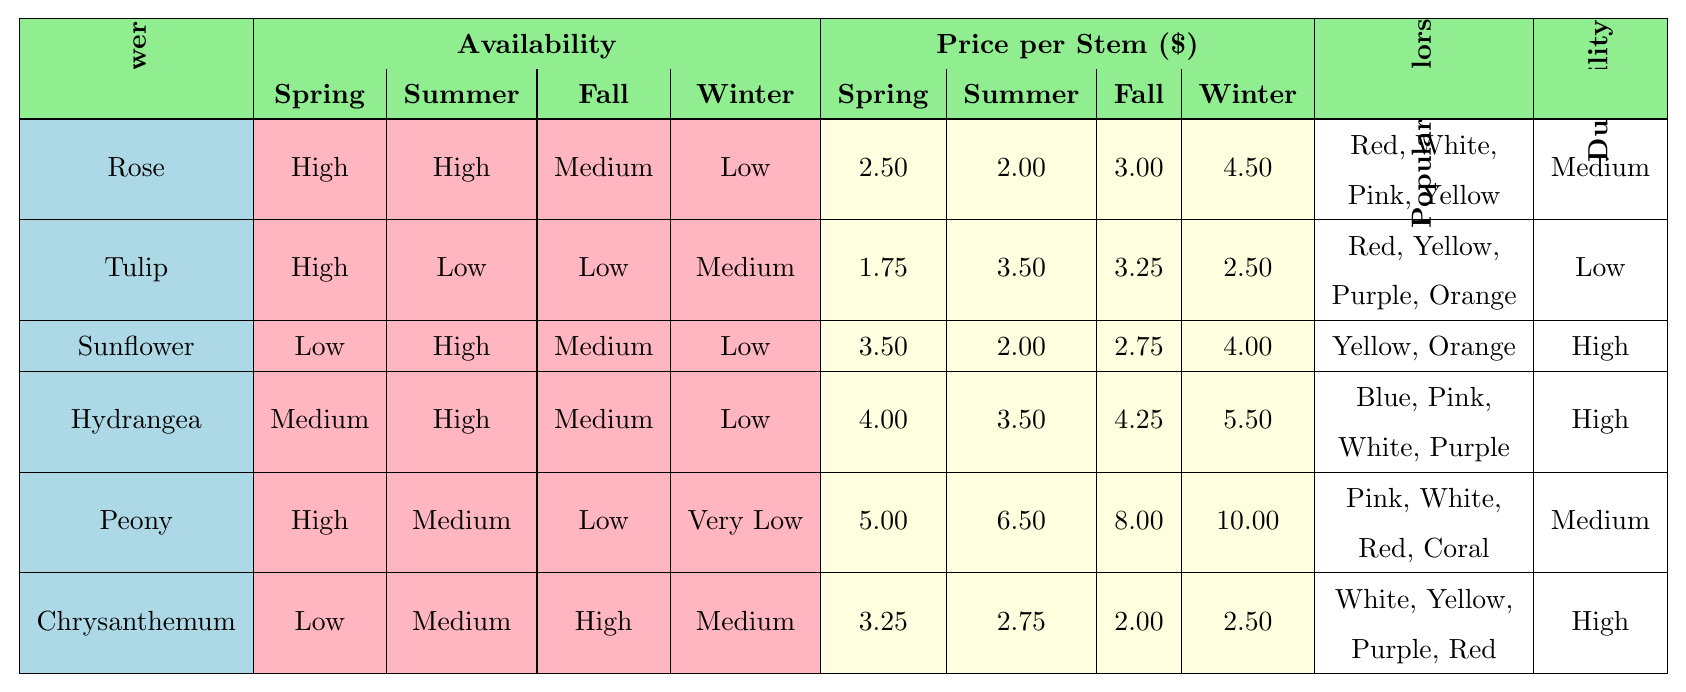What flower is available in every season? By checking the availability of each flower across the four seasons, we see that no flower has high or medium availability in all seasons. Therefore, there is no flower that is available in every season.
Answer: No flower Which flower has the highest price per stem in winter? Looking at the winter prices for each flower, the Peony has the highest price per stem at $10.00.
Answer: Peony What is the average spring price for flowers available in spring? The flowers available in spring are Rose, Tulip, Peony, and Hydrangea. Their prices are $2.50, $1.75, $5.00, and $4.00 respectively. The average is (2.50 + 1.75 + 5.00 + 4.00) / 4 = 13.25 / 4 = 3.3125.
Answer: $3.31 Do any flowers have high durability but low winter availability? Checking the durability and winter availability, Sunflower and Hydrangea have high durability; however, the Sunflower has low winter availability. Therefore, the answer is yes.
Answer: Yes Which season has the lowest price for Sunflowers? By examining the price per stem for Sunflowers across different seasons, summer has the lowest price at $2.00.
Answer: Summer How many flowers have high availability in the summer? The flowers with high summer availability are Sunflower and Hydrangea. Thus, the count is 2.
Answer: 2 Which flower has the lowest price per stem in fall? We look at the fall prices for each flower and find that Chrysanthemum has the lowest price per stem at $2.00.
Answer: Chrysanthemum If I want to use flowers that are available in both spring and summer, which should I choose? The flowers that are available in both spring and summer are Rose and Hydrangea.
Answer: Rose, Hydrangea Is it true that Peonies are only available in spring? The table shows that Peonies have high availability in spring, medium in summer, low in fall, and very low in winter; therefore, it is false that they are only available in spring.
Answer: False What’s the price difference between the summer and winter prices for Hydrangeas? The summer price for Hydrangeas is $3.50, and the winter price is $5.50. The difference is 5.50 - 3.50 = $2.00.
Answer: $2.00 